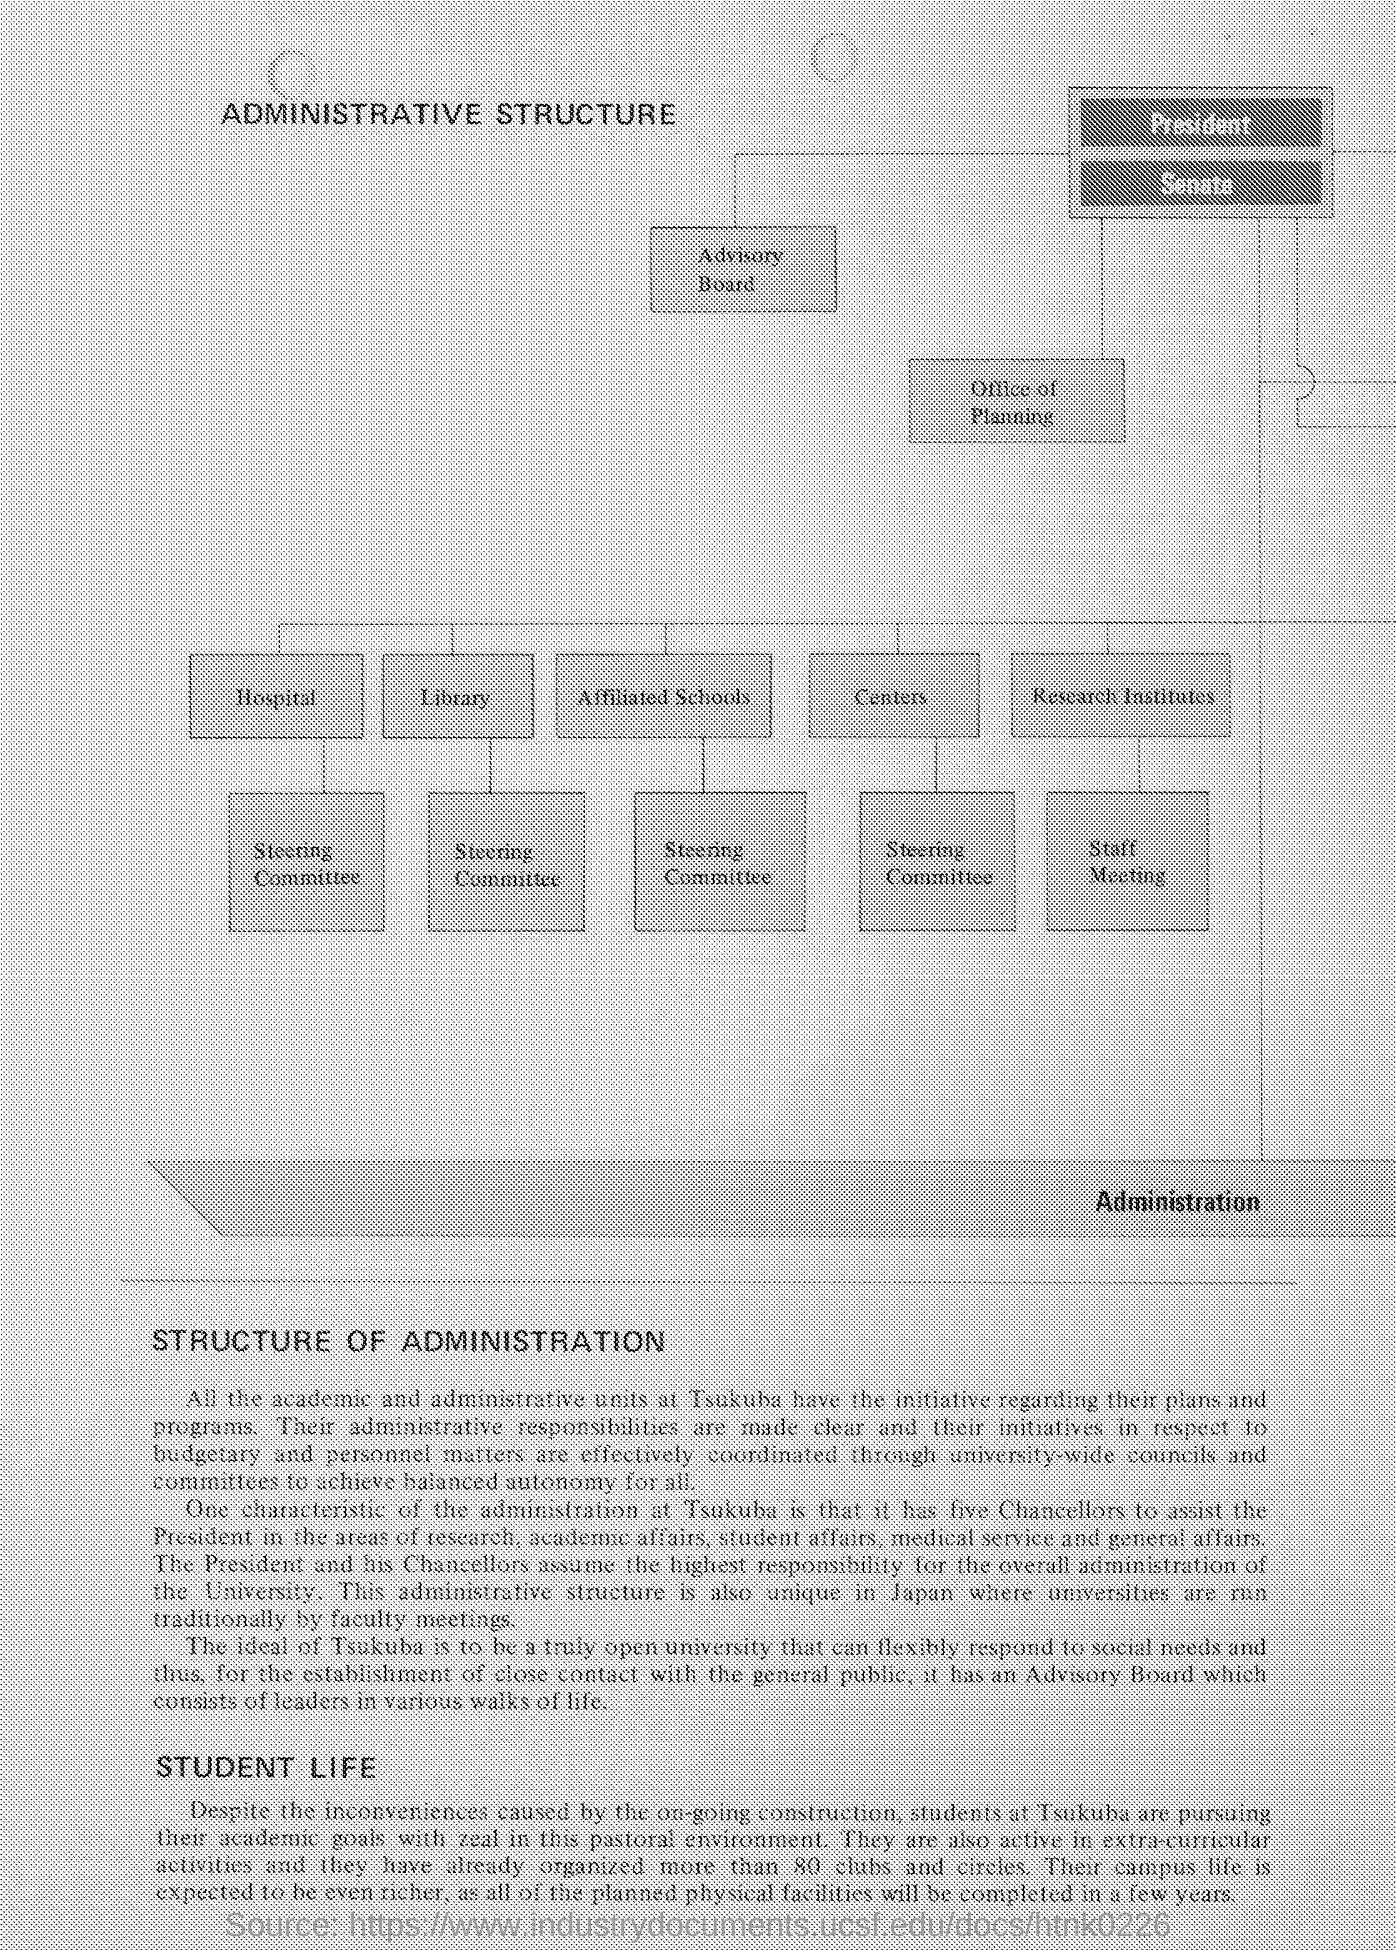What is the heading of the document ?
Your response must be concise. Administrative Structure. What is the source of this document?
Provide a short and direct response. Https://www.industrydocuments.ucsf.edu/docs/htnk0226. How many clubs and circles are there in Tsukaba?
Your response must be concise. More than 80. Who all are included in "Advisory board" ?
Provide a short and direct response. Leaders in various walks of life. Who all assume the highest responsibility for the overall administration of the university?
Make the answer very short. The President and his Chancellors. How many chancellors are there to assist the president ?
Your response must be concise. Five. What comes below the 'Research Institutes' in the flow diagram ?
Your answer should be very brief. Staff Meeting. What all at Tsukuba have the initiative regarding their plans and programs?
Provide a succinct answer. All the academic and administrative units. 